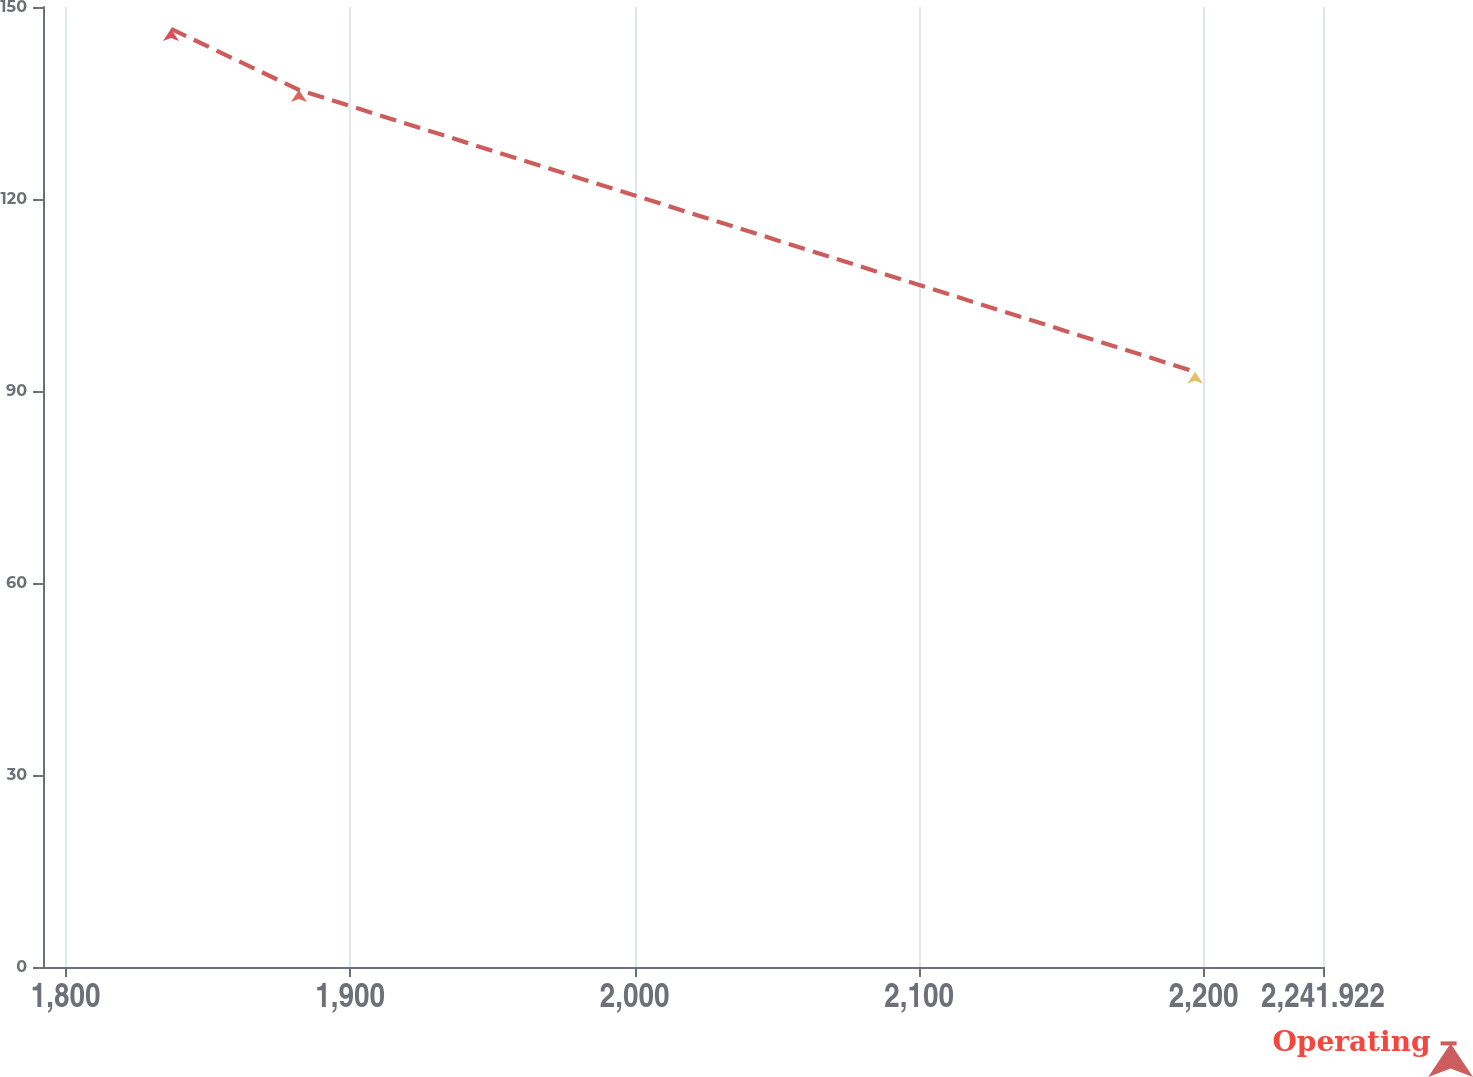Convert chart to OTSL. <chart><loc_0><loc_0><loc_500><loc_500><line_chart><ecel><fcel>Operating<nl><fcel>1837.03<fcel>146.58<nl><fcel>1882<fcel>137.05<nl><fcel>2196.97<fcel>93.01<nl><fcel>2241.94<fcel>59.46<nl><fcel>2286.91<fcel>47.42<nl></chart> 